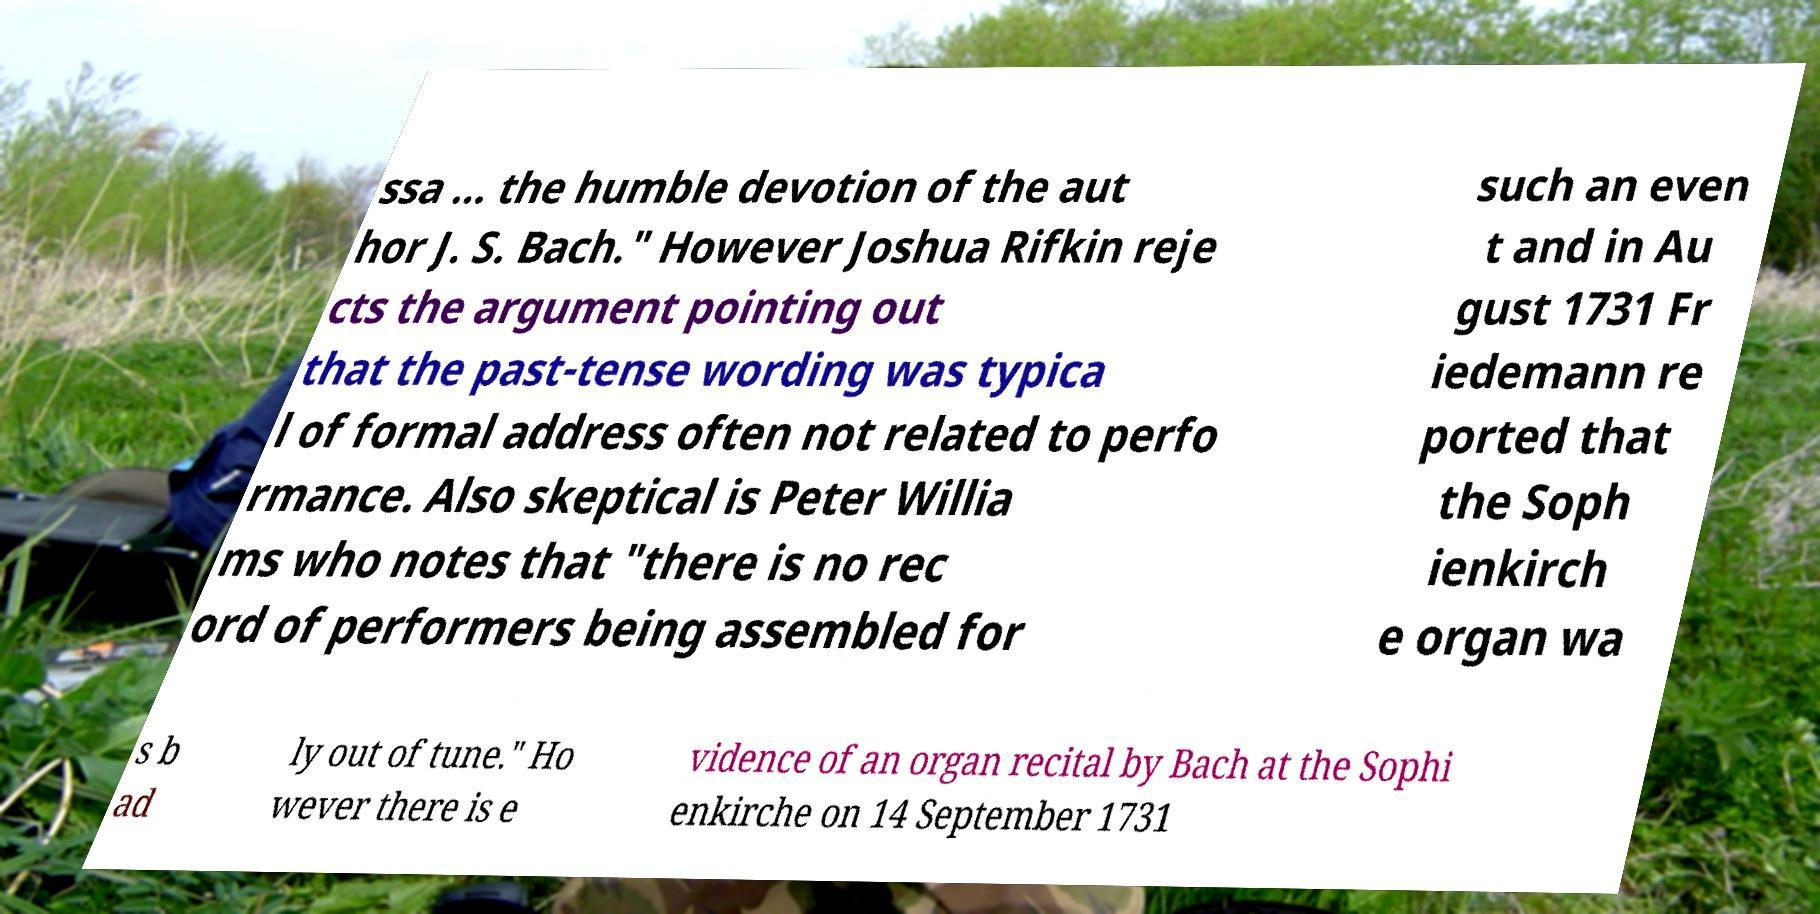There's text embedded in this image that I need extracted. Can you transcribe it verbatim? ssa ... the humble devotion of the aut hor J. S. Bach." However Joshua Rifkin reje cts the argument pointing out that the past-tense wording was typica l of formal address often not related to perfo rmance. Also skeptical is Peter Willia ms who notes that "there is no rec ord of performers being assembled for such an even t and in Au gust 1731 Fr iedemann re ported that the Soph ienkirch e organ wa s b ad ly out of tune." Ho wever there is e vidence of an organ recital by Bach at the Sophi enkirche on 14 September 1731 